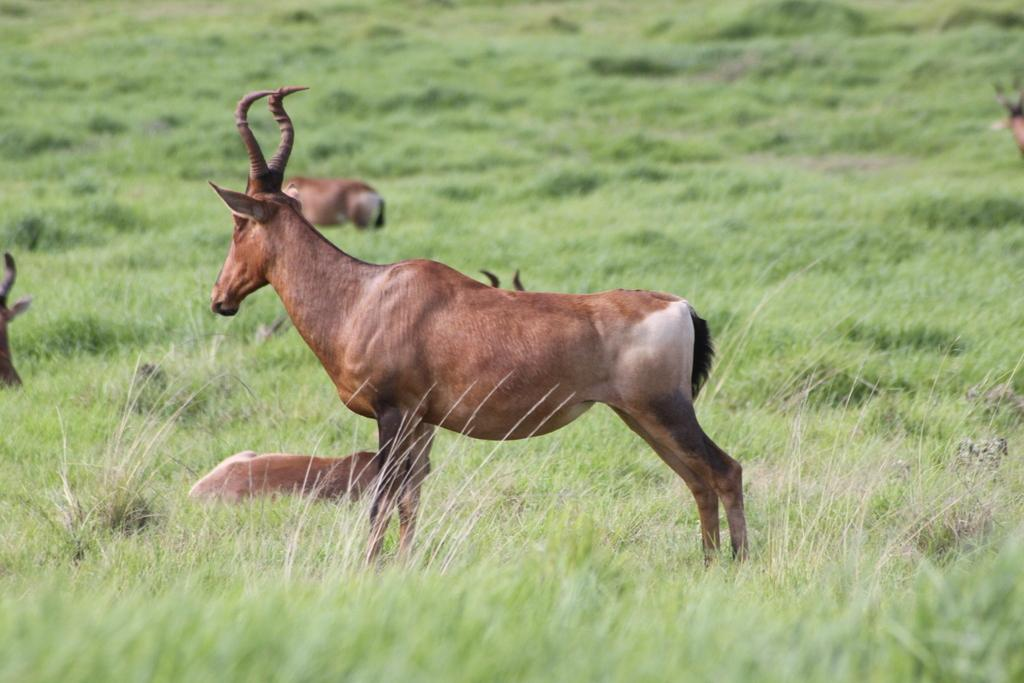What type of living organisms can be seen in the image? There are animals in the image. Where are the animals located? The animals are on the grass. What type of riddle can be solved by the animals in the image? There is no riddle present in the image, nor is there any indication that the animals are solving a riddle. 